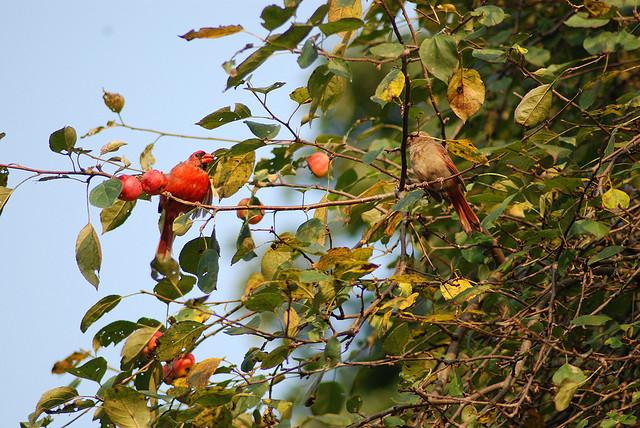Why is there only one bird feeding?
Be succinct. 2. Does this show a male and female cardinal?
Write a very short answer. Yes. Are there red things on the branches?
Quick response, please. Yes. What type of tree is the bird on?
Quick response, please. Apple. What is the bird eating?
Quick response, please. Fruit. What color is the birds breast?
Concise answer only. Red. Could this fruit be citrus?
Answer briefly. No. What color is the bird's beak in the back?
Concise answer only. Red. What color is the parrot?
Be succinct. Red. What color are the leaf's?
Give a very brief answer. Green. What color are the leaves?
Quick response, please. Green. What kind of bird is this?
Answer briefly. Cardinal. What color is the bird's head?
Keep it brief. Red. 